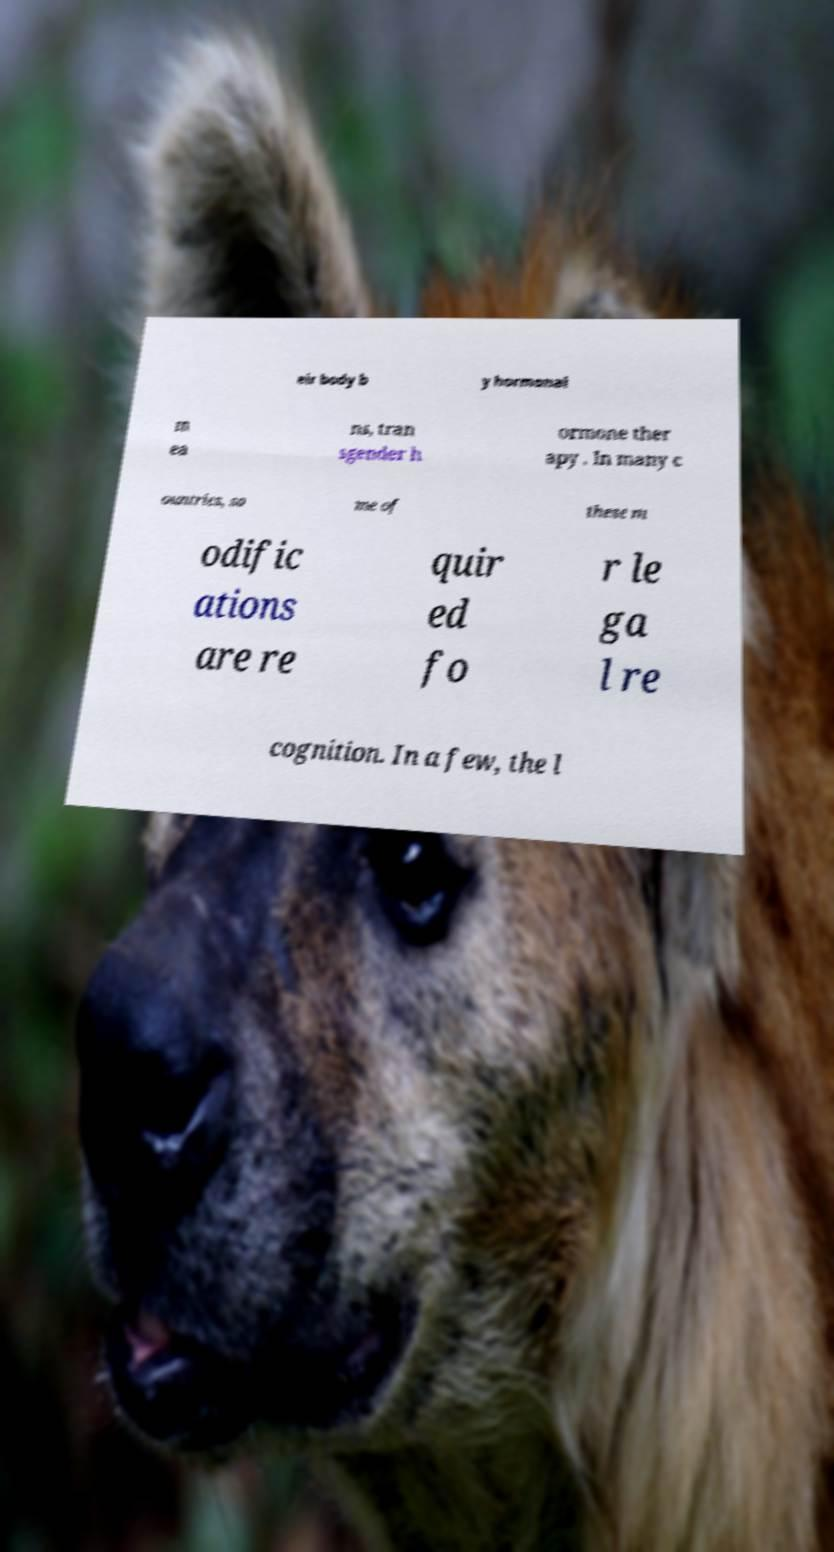Please identify and transcribe the text found in this image. eir body b y hormonal m ea ns, tran sgender h ormone ther apy . In many c ountries, so me of these m odific ations are re quir ed fo r le ga l re cognition. In a few, the l 